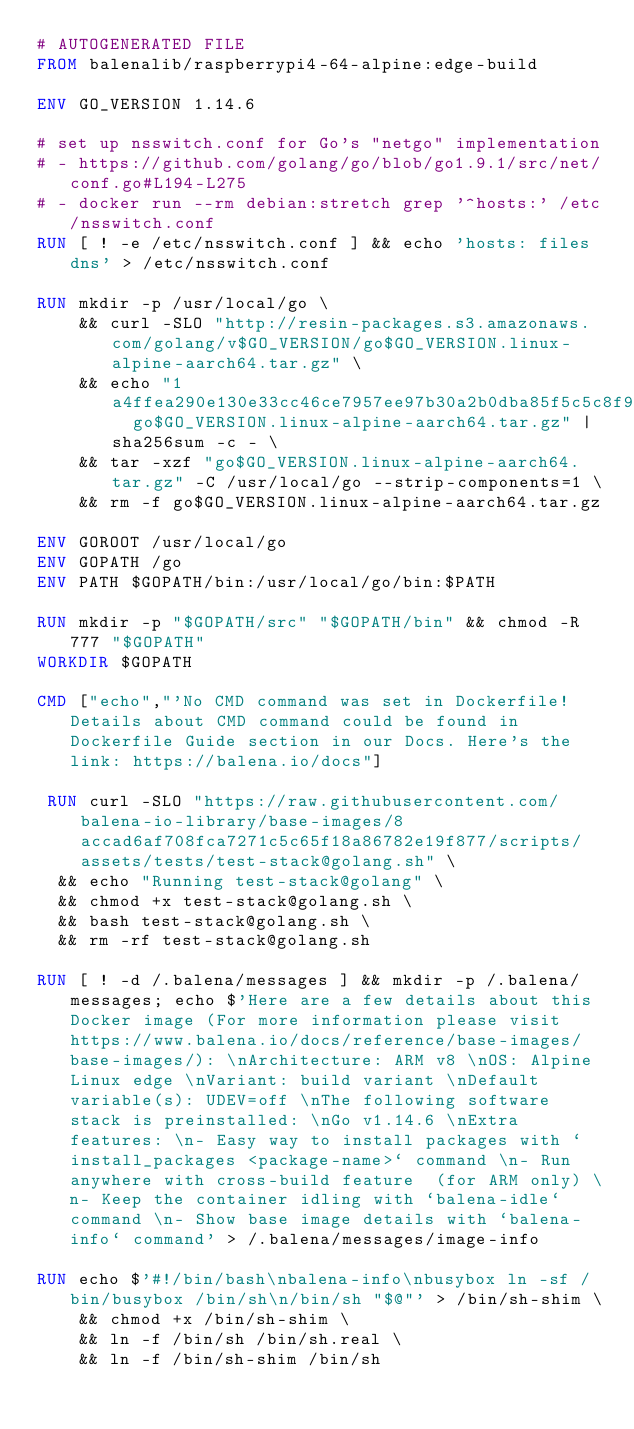Convert code to text. <code><loc_0><loc_0><loc_500><loc_500><_Dockerfile_># AUTOGENERATED FILE
FROM balenalib/raspberrypi4-64-alpine:edge-build

ENV GO_VERSION 1.14.6

# set up nsswitch.conf for Go's "netgo" implementation
# - https://github.com/golang/go/blob/go1.9.1/src/net/conf.go#L194-L275
# - docker run --rm debian:stretch grep '^hosts:' /etc/nsswitch.conf
RUN [ ! -e /etc/nsswitch.conf ] && echo 'hosts: files dns' > /etc/nsswitch.conf

RUN mkdir -p /usr/local/go \
	&& curl -SLO "http://resin-packages.s3.amazonaws.com/golang/v$GO_VERSION/go$GO_VERSION.linux-alpine-aarch64.tar.gz" \
	&& echo "1a4ffea290e130e33cc46ce7957ee97b30a2b0dba85f5c5c8f91f614f3f5a9c5  go$GO_VERSION.linux-alpine-aarch64.tar.gz" | sha256sum -c - \
	&& tar -xzf "go$GO_VERSION.linux-alpine-aarch64.tar.gz" -C /usr/local/go --strip-components=1 \
	&& rm -f go$GO_VERSION.linux-alpine-aarch64.tar.gz

ENV GOROOT /usr/local/go
ENV GOPATH /go
ENV PATH $GOPATH/bin:/usr/local/go/bin:$PATH

RUN mkdir -p "$GOPATH/src" "$GOPATH/bin" && chmod -R 777 "$GOPATH"
WORKDIR $GOPATH

CMD ["echo","'No CMD command was set in Dockerfile! Details about CMD command could be found in Dockerfile Guide section in our Docs. Here's the link: https://balena.io/docs"]

 RUN curl -SLO "https://raw.githubusercontent.com/balena-io-library/base-images/8accad6af708fca7271c5c65f18a86782e19f877/scripts/assets/tests/test-stack@golang.sh" \
  && echo "Running test-stack@golang" \
  && chmod +x test-stack@golang.sh \
  && bash test-stack@golang.sh \
  && rm -rf test-stack@golang.sh 

RUN [ ! -d /.balena/messages ] && mkdir -p /.balena/messages; echo $'Here are a few details about this Docker image (For more information please visit https://www.balena.io/docs/reference/base-images/base-images/): \nArchitecture: ARM v8 \nOS: Alpine Linux edge \nVariant: build variant \nDefault variable(s): UDEV=off \nThe following software stack is preinstalled: \nGo v1.14.6 \nExtra features: \n- Easy way to install packages with `install_packages <package-name>` command \n- Run anywhere with cross-build feature  (for ARM only) \n- Keep the container idling with `balena-idle` command \n- Show base image details with `balena-info` command' > /.balena/messages/image-info

RUN echo $'#!/bin/bash\nbalena-info\nbusybox ln -sf /bin/busybox /bin/sh\n/bin/sh "$@"' > /bin/sh-shim \
	&& chmod +x /bin/sh-shim \
	&& ln -f /bin/sh /bin/sh.real \
	&& ln -f /bin/sh-shim /bin/sh</code> 